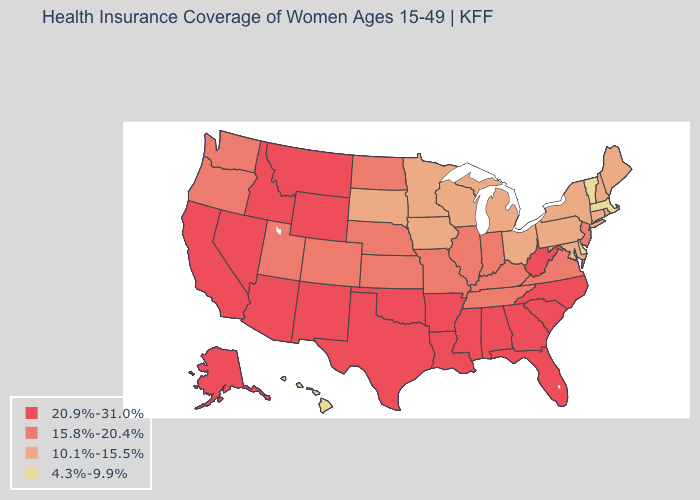What is the highest value in states that border Indiana?
Short answer required. 15.8%-20.4%. What is the highest value in the West ?
Give a very brief answer. 20.9%-31.0%. Does the first symbol in the legend represent the smallest category?
Be succinct. No. Name the states that have a value in the range 4.3%-9.9%?
Answer briefly. Delaware, Hawaii, Massachusetts, Vermont. Which states have the lowest value in the USA?
Be succinct. Delaware, Hawaii, Massachusetts, Vermont. Does Alabama have the highest value in the South?
Quick response, please. Yes. What is the value of Iowa?
Short answer required. 10.1%-15.5%. What is the value of Arkansas?
Answer briefly. 20.9%-31.0%. How many symbols are there in the legend?
Concise answer only. 4. What is the value of Pennsylvania?
Answer briefly. 10.1%-15.5%. What is the value of Louisiana?
Concise answer only. 20.9%-31.0%. What is the value of California?
Concise answer only. 20.9%-31.0%. Among the states that border South Carolina , which have the highest value?
Short answer required. Georgia, North Carolina. Does Alabama have the lowest value in the South?
Keep it brief. No. Which states have the highest value in the USA?
Be succinct. Alabama, Alaska, Arizona, Arkansas, California, Florida, Georgia, Idaho, Louisiana, Mississippi, Montana, Nevada, New Mexico, North Carolina, Oklahoma, South Carolina, Texas, West Virginia, Wyoming. 